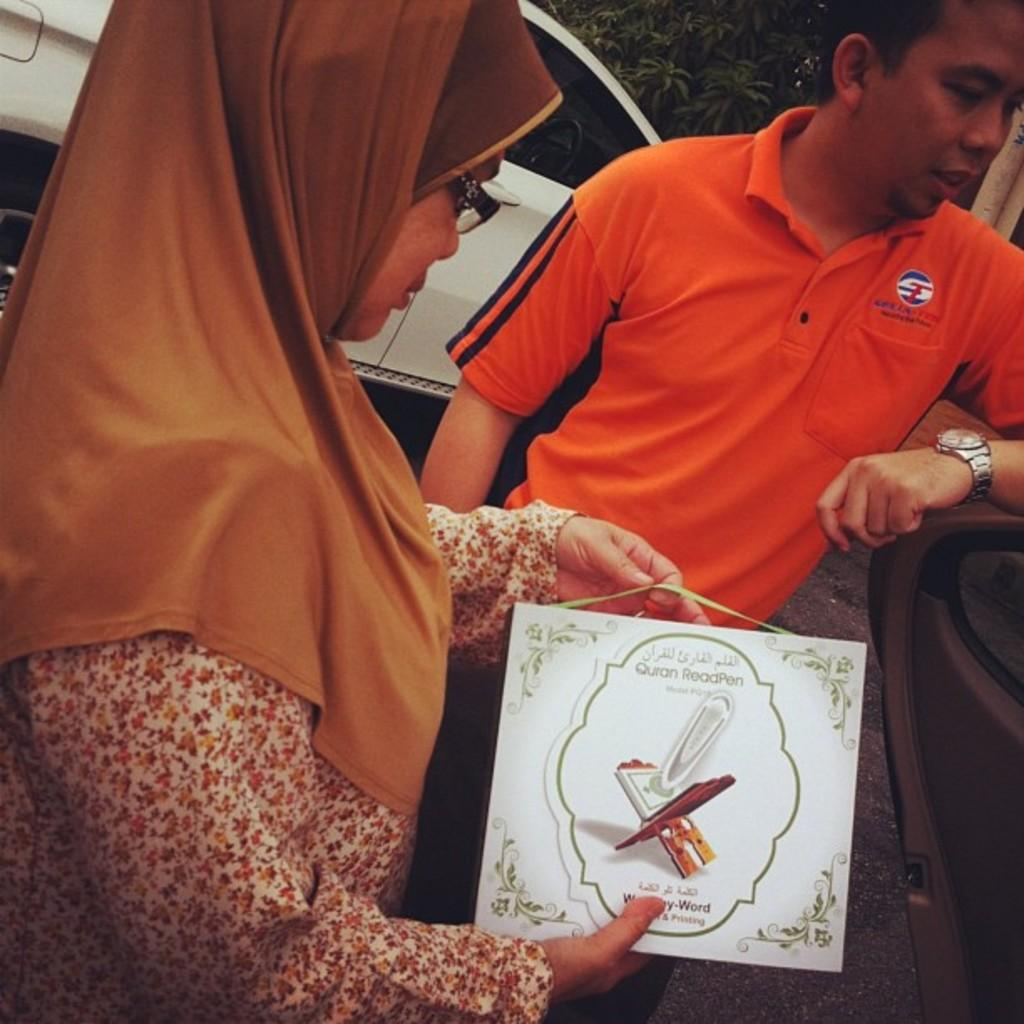How many people are present in the image? There are two persons standing in the image. What is visible in the background of the image? There is a vehicle and a tree in the background of the image. How many babies are visible in the image? There are no babies present in the image. What type of musical instrument is being played by one of the persons in the image? There is no musical instrument, such as a guitar, visible in the image. 